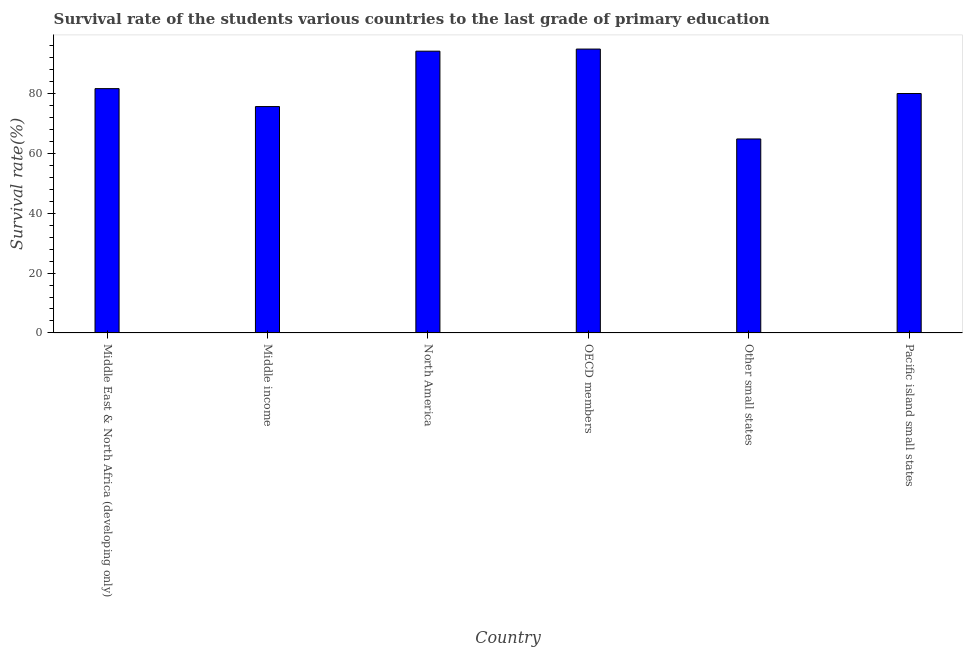Does the graph contain grids?
Make the answer very short. No. What is the title of the graph?
Make the answer very short. Survival rate of the students various countries to the last grade of primary education. What is the label or title of the Y-axis?
Your answer should be very brief. Survival rate(%). What is the survival rate in primary education in Other small states?
Ensure brevity in your answer.  64.82. Across all countries, what is the maximum survival rate in primary education?
Offer a very short reply. 94.86. Across all countries, what is the minimum survival rate in primary education?
Your answer should be very brief. 64.82. In which country was the survival rate in primary education maximum?
Make the answer very short. OECD members. In which country was the survival rate in primary education minimum?
Make the answer very short. Other small states. What is the sum of the survival rate in primary education?
Give a very brief answer. 491.13. What is the difference between the survival rate in primary education in Middle East & North Africa (developing only) and Other small states?
Ensure brevity in your answer.  16.82. What is the average survival rate in primary education per country?
Offer a very short reply. 81.86. What is the median survival rate in primary education?
Provide a short and direct response. 80.82. In how many countries, is the survival rate in primary education greater than 64 %?
Your answer should be very brief. 6. What is the ratio of the survival rate in primary education in Middle East & North Africa (developing only) to that in OECD members?
Your answer should be compact. 0.86. Is the survival rate in primary education in Middle income less than that in Other small states?
Offer a terse response. No. What is the difference between the highest and the second highest survival rate in primary education?
Your answer should be very brief. 0.7. Is the sum of the survival rate in primary education in North America and Pacific island small states greater than the maximum survival rate in primary education across all countries?
Keep it short and to the point. Yes. What is the difference between the highest and the lowest survival rate in primary education?
Your response must be concise. 30.04. How many bars are there?
Your response must be concise. 6. Are all the bars in the graph horizontal?
Make the answer very short. No. How many countries are there in the graph?
Make the answer very short. 6. What is the difference between two consecutive major ticks on the Y-axis?
Make the answer very short. 20. What is the Survival rate(%) of Middle East & North Africa (developing only)?
Offer a terse response. 81.64. What is the Survival rate(%) of Middle income?
Offer a terse response. 75.65. What is the Survival rate(%) of North America?
Provide a short and direct response. 94.16. What is the Survival rate(%) of OECD members?
Your answer should be compact. 94.86. What is the Survival rate(%) in Other small states?
Provide a succinct answer. 64.82. What is the Survival rate(%) of Pacific island small states?
Keep it short and to the point. 80. What is the difference between the Survival rate(%) in Middle East & North Africa (developing only) and Middle income?
Give a very brief answer. 5.99. What is the difference between the Survival rate(%) in Middle East & North Africa (developing only) and North America?
Your answer should be very brief. -12.52. What is the difference between the Survival rate(%) in Middle East & North Africa (developing only) and OECD members?
Keep it short and to the point. -13.22. What is the difference between the Survival rate(%) in Middle East & North Africa (developing only) and Other small states?
Your answer should be compact. 16.82. What is the difference between the Survival rate(%) in Middle East & North Africa (developing only) and Pacific island small states?
Ensure brevity in your answer.  1.63. What is the difference between the Survival rate(%) in Middle income and North America?
Your answer should be very brief. -18.51. What is the difference between the Survival rate(%) in Middle income and OECD members?
Keep it short and to the point. -19.21. What is the difference between the Survival rate(%) in Middle income and Other small states?
Provide a succinct answer. 10.82. What is the difference between the Survival rate(%) in Middle income and Pacific island small states?
Ensure brevity in your answer.  -4.36. What is the difference between the Survival rate(%) in North America and OECD members?
Give a very brief answer. -0.7. What is the difference between the Survival rate(%) in North America and Other small states?
Offer a terse response. 29.33. What is the difference between the Survival rate(%) in North America and Pacific island small states?
Your answer should be compact. 14.15. What is the difference between the Survival rate(%) in OECD members and Other small states?
Make the answer very short. 30.04. What is the difference between the Survival rate(%) in OECD members and Pacific island small states?
Make the answer very short. 14.86. What is the difference between the Survival rate(%) in Other small states and Pacific island small states?
Give a very brief answer. -15.18. What is the ratio of the Survival rate(%) in Middle East & North Africa (developing only) to that in Middle income?
Give a very brief answer. 1.08. What is the ratio of the Survival rate(%) in Middle East & North Africa (developing only) to that in North America?
Your response must be concise. 0.87. What is the ratio of the Survival rate(%) in Middle East & North Africa (developing only) to that in OECD members?
Ensure brevity in your answer.  0.86. What is the ratio of the Survival rate(%) in Middle East & North Africa (developing only) to that in Other small states?
Offer a very short reply. 1.26. What is the ratio of the Survival rate(%) in Middle East & North Africa (developing only) to that in Pacific island small states?
Provide a short and direct response. 1.02. What is the ratio of the Survival rate(%) in Middle income to that in North America?
Your answer should be very brief. 0.8. What is the ratio of the Survival rate(%) in Middle income to that in OECD members?
Your answer should be compact. 0.8. What is the ratio of the Survival rate(%) in Middle income to that in Other small states?
Offer a terse response. 1.17. What is the ratio of the Survival rate(%) in Middle income to that in Pacific island small states?
Make the answer very short. 0.95. What is the ratio of the Survival rate(%) in North America to that in OECD members?
Provide a short and direct response. 0.99. What is the ratio of the Survival rate(%) in North America to that in Other small states?
Provide a short and direct response. 1.45. What is the ratio of the Survival rate(%) in North America to that in Pacific island small states?
Make the answer very short. 1.18. What is the ratio of the Survival rate(%) in OECD members to that in Other small states?
Your answer should be compact. 1.46. What is the ratio of the Survival rate(%) in OECD members to that in Pacific island small states?
Make the answer very short. 1.19. What is the ratio of the Survival rate(%) in Other small states to that in Pacific island small states?
Ensure brevity in your answer.  0.81. 